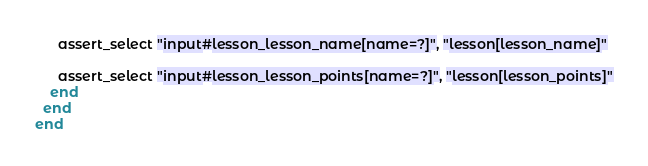Convert code to text. <code><loc_0><loc_0><loc_500><loc_500><_Ruby_>      assert_select "input#lesson_lesson_name[name=?]", "lesson[lesson_name]"

      assert_select "input#lesson_lesson_points[name=?]", "lesson[lesson_points]"
    end
  end
end
</code> 